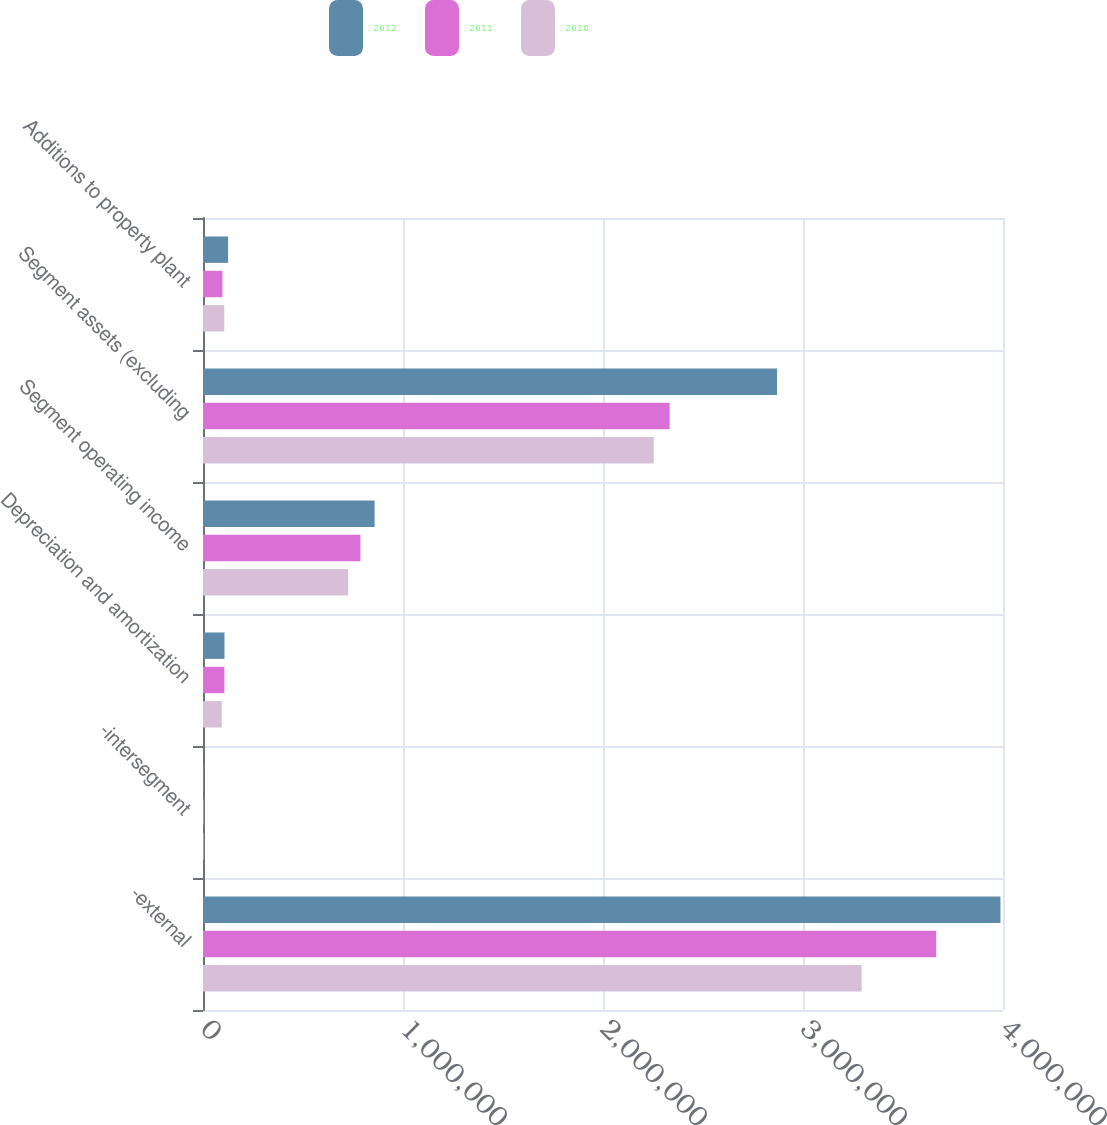Convert chart. <chart><loc_0><loc_0><loc_500><loc_500><stacked_bar_chart><ecel><fcel>-external<fcel>-intersegment<fcel>Depreciation and amortization<fcel>Segment operating income<fcel>Segment assets (excluding<fcel>Additions to property plant<nl><fcel>2012<fcel>3.98729e+06<fcel>4928<fcel>107466<fcel>858066<fcel>2.87028e+06<fcel>125527<nl><fcel>2011<fcel>3.66604e+06<fcel>5645<fcel>107021<fcel>787323<fcel>2.33325e+06<fcel>97459<nl><fcel>2010<fcel>3.29312e+06<fcel>3002<fcel>93641<fcel>725946<fcel>2.25364e+06<fcel>106267<nl></chart> 